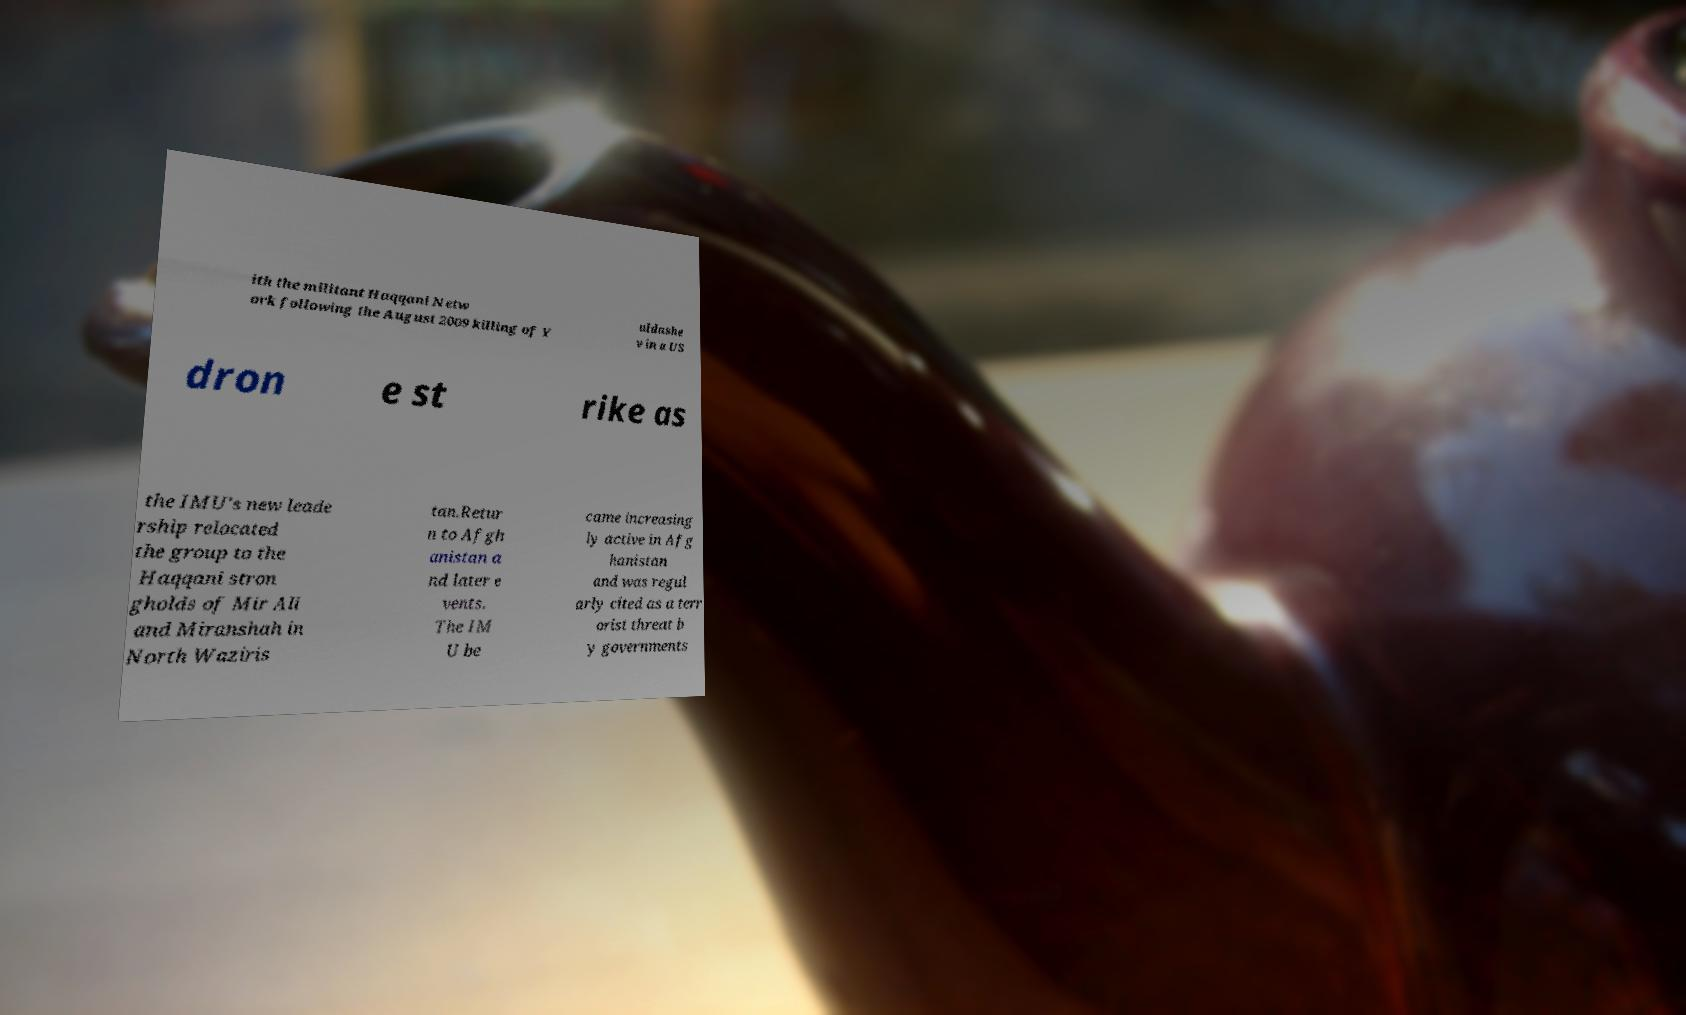Can you read and provide the text displayed in the image?This photo seems to have some interesting text. Can you extract and type it out for me? ith the militant Haqqani Netw ork following the August 2009 killing of Y uldashe v in a US dron e st rike as the IMU's new leade rship relocated the group to the Haqqani stron gholds of Mir Ali and Miranshah in North Waziris tan.Retur n to Afgh anistan a nd later e vents. The IM U be came increasing ly active in Afg hanistan and was regul arly cited as a terr orist threat b y governments 